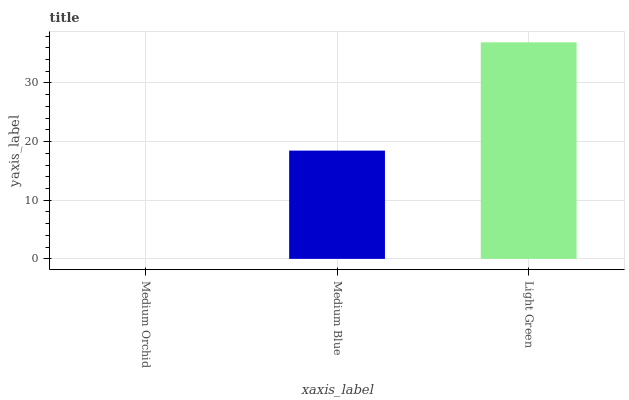Is Medium Orchid the minimum?
Answer yes or no. Yes. Is Light Green the maximum?
Answer yes or no. Yes. Is Medium Blue the minimum?
Answer yes or no. No. Is Medium Blue the maximum?
Answer yes or no. No. Is Medium Blue greater than Medium Orchid?
Answer yes or no. Yes. Is Medium Orchid less than Medium Blue?
Answer yes or no. Yes. Is Medium Orchid greater than Medium Blue?
Answer yes or no. No. Is Medium Blue less than Medium Orchid?
Answer yes or no. No. Is Medium Blue the high median?
Answer yes or no. Yes. Is Medium Blue the low median?
Answer yes or no. Yes. Is Light Green the high median?
Answer yes or no. No. Is Medium Orchid the low median?
Answer yes or no. No. 